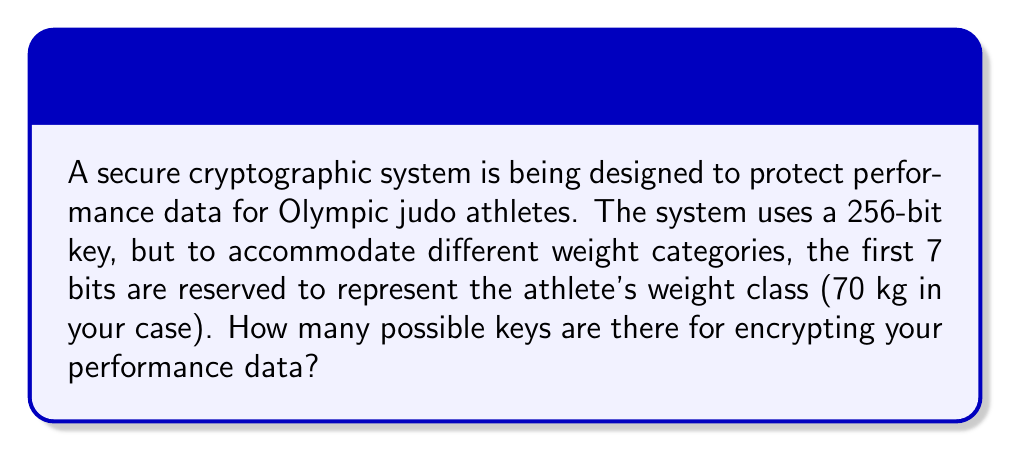Teach me how to tackle this problem. Let's approach this step-by-step:

1) The total key length is 256 bits.

2) 7 bits are reserved for the weight class, leaving 249 bits for the actual encryption key.

3) In binary, each bit can be either 0 or 1, giving 2 possibilities per bit.

4) For a 249-bit key, the number of possible combinations is:

   $$2^{249}$$

5) To calculate this:
   
   $$2^{249} = 2 \times 2^{248} = 2 \times (2^{8})^{31} = 2 \times 256^{31}$$

6) This is an extremely large number, approximately equal to:

   $$4.5 \times 10^{75}$$

Therefore, there are approximately $4.5 \times 10^{75}$ possible keys for encrypting your performance data.
Answer: $2^{249}$ or approximately $4.5 \times 10^{75}$ 